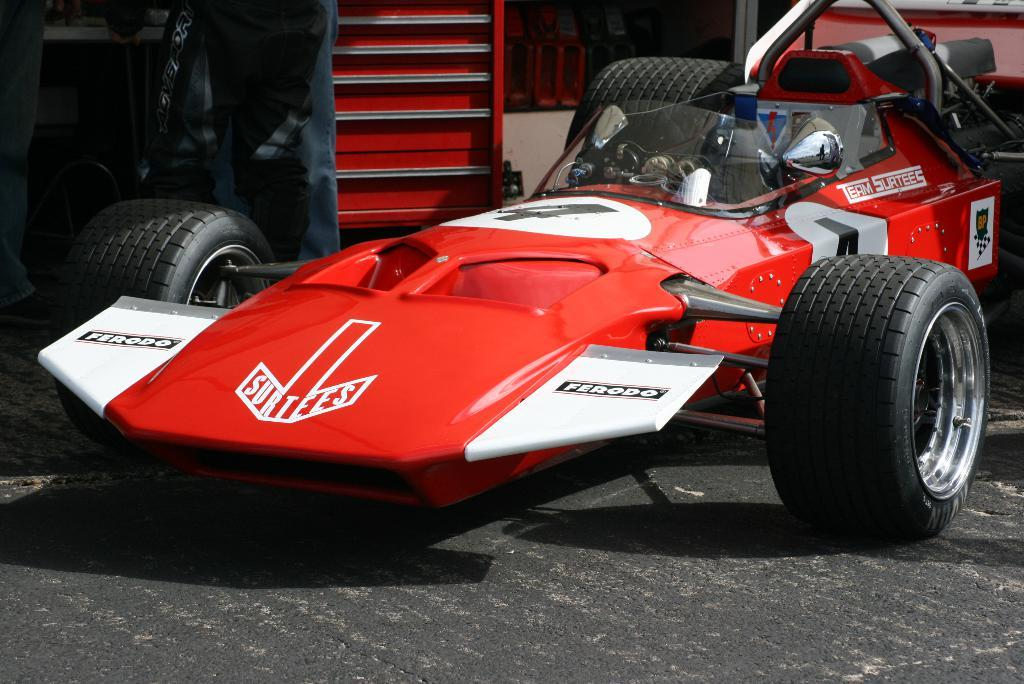What is the main subject of the image? The main subject of the image is a racing car. What color is the racing car? The racing car is colored red. What architectural feature can be seen at the top of the image? There are stairs at the top of the image. What news headline is displayed on the racing car in the image? There is no news headline displayed on the racing car in the image; it is a red racing car with no text or images other than the car itself. 